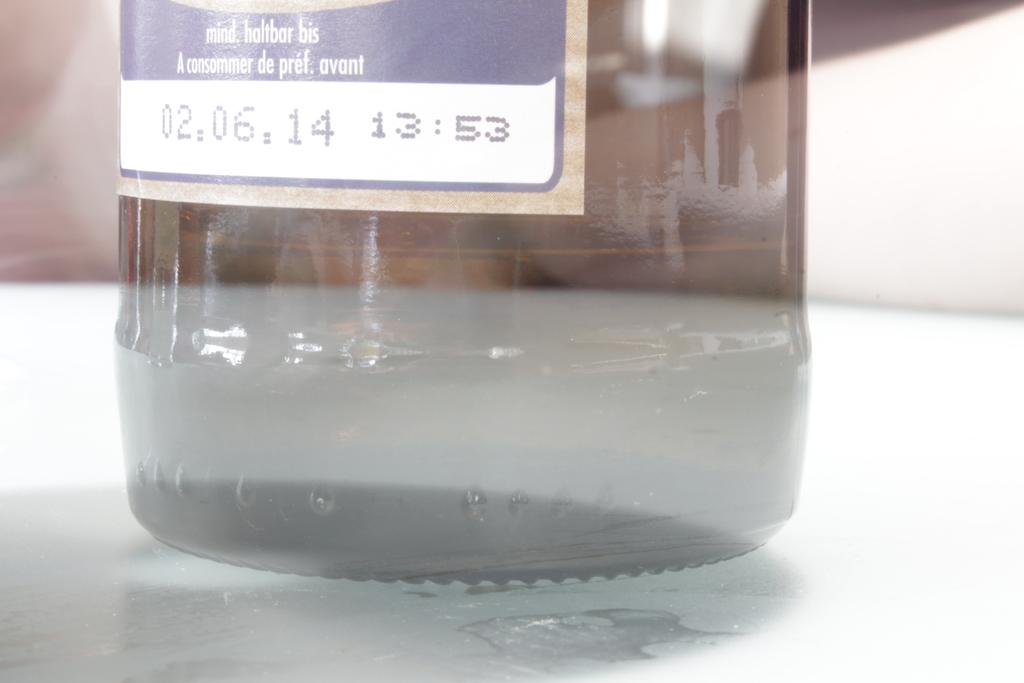<image>
Render a clear and concise summary of the photo. The bottom portion of a bottle with an expiration date of 02/06/2014. 